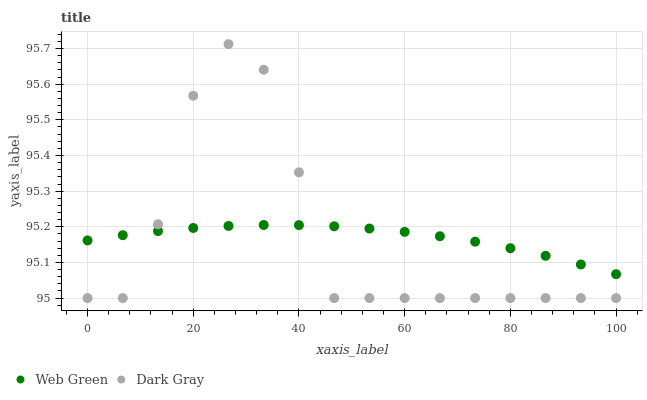Does Dark Gray have the minimum area under the curve?
Answer yes or no. Yes. Does Web Green have the maximum area under the curve?
Answer yes or no. Yes. Does Web Green have the minimum area under the curve?
Answer yes or no. No. Is Web Green the smoothest?
Answer yes or no. Yes. Is Dark Gray the roughest?
Answer yes or no. Yes. Is Web Green the roughest?
Answer yes or no. No. Does Dark Gray have the lowest value?
Answer yes or no. Yes. Does Web Green have the lowest value?
Answer yes or no. No. Does Dark Gray have the highest value?
Answer yes or no. Yes. Does Web Green have the highest value?
Answer yes or no. No. Does Dark Gray intersect Web Green?
Answer yes or no. Yes. Is Dark Gray less than Web Green?
Answer yes or no. No. Is Dark Gray greater than Web Green?
Answer yes or no. No. 